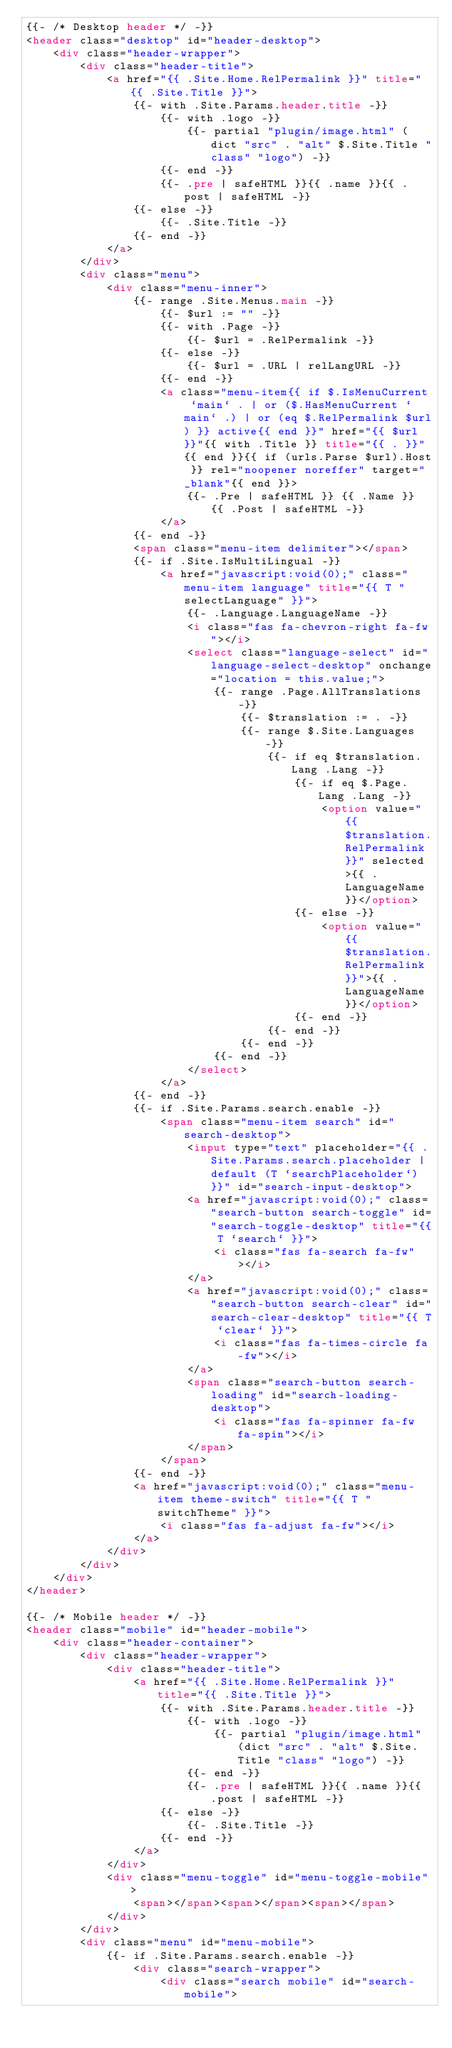<code> <loc_0><loc_0><loc_500><loc_500><_HTML_>{{- /* Desktop header */ -}}
<header class="desktop" id="header-desktop">
    <div class="header-wrapper">
        <div class="header-title">
            <a href="{{ .Site.Home.RelPermalink }}" title="{{ .Site.Title }}">
                {{- with .Site.Params.header.title -}}
                    {{- with .logo -}}
                        {{- partial "plugin/image.html" (dict "src" . "alt" $.Site.Title "class" "logo") -}}
                    {{- end -}}
                    {{- .pre | safeHTML }}{{ .name }}{{ .post | safeHTML -}}
                {{- else -}}
                    {{- .Site.Title -}}
                {{- end -}}
            </a>
        </div>
        <div class="menu">
            <div class="menu-inner">
                {{- range .Site.Menus.main -}}
                    {{- $url := "" -}}
                    {{- with .Page -}}
                        {{- $url = .RelPermalink -}}
                    {{- else -}}
                        {{- $url = .URL | relLangURL -}}
                    {{- end -}}
                    <a class="menu-item{{ if $.IsMenuCurrent `main` . | or ($.HasMenuCurrent `main` .) | or (eq $.RelPermalink $url) }} active{{ end }}" href="{{ $url }}"{{ with .Title }} title="{{ . }}"{{ end }}{{ if (urls.Parse $url).Host }} rel="noopener noreffer" target="_blank"{{ end }}>
                        {{- .Pre | safeHTML }} {{ .Name }} {{ .Post | safeHTML -}}
                    </a>
                {{- end -}}
                <span class="menu-item delimiter"></span>
                {{- if .Site.IsMultiLingual -}}
                    <a href="javascript:void(0);" class="menu-item language" title="{{ T "selectLanguage" }}">
                        {{- .Language.LanguageName -}}
                        <i class="fas fa-chevron-right fa-fw"></i>
                        <select class="language-select" id="language-select-desktop" onchange="location = this.value;">
                            {{- range .Page.AllTranslations -}}
                                {{- $translation := . -}}
                                {{- range $.Site.Languages -}}
                                    {{- if eq $translation.Lang .Lang -}}
                                        {{- if eq $.Page.Lang .Lang -}}
                                            <option value="{{ $translation.RelPermalink }}" selected>{{ .LanguageName }}</option>
                                        {{- else -}}
                                            <option value="{{ $translation.RelPermalink }}">{{ .LanguageName }}</option>
                                        {{- end -}}
                                    {{- end -}}
                                {{- end -}}
                            {{- end -}}
                        </select>
                    </a>
                {{- end -}}
                {{- if .Site.Params.search.enable -}}
                    <span class="menu-item search" id="search-desktop">
                        <input type="text" placeholder="{{ .Site.Params.search.placeholder | default (T `searchPlaceholder`) }}" id="search-input-desktop">
                        <a href="javascript:void(0);" class="search-button search-toggle" id="search-toggle-desktop" title="{{ T `search` }}">
                            <i class="fas fa-search fa-fw"></i>
                        </a>
                        <a href="javascript:void(0);" class="search-button search-clear" id="search-clear-desktop" title="{{ T `clear` }}">
                            <i class="fas fa-times-circle fa-fw"></i>
                        </a>
                        <span class="search-button search-loading" id="search-loading-desktop">
                            <i class="fas fa-spinner fa-fw fa-spin"></i>
                        </span>
                    </span>
                {{- end -}}
                <a href="javascript:void(0);" class="menu-item theme-switch" title="{{ T "switchTheme" }}">
                    <i class="fas fa-adjust fa-fw"></i>
                </a>
            </div>
        </div>
    </div>
</header>

{{- /* Mobile header */ -}}
<header class="mobile" id="header-mobile">
    <div class="header-container">
        <div class="header-wrapper">
            <div class="header-title">
                <a href="{{ .Site.Home.RelPermalink }}" title="{{ .Site.Title }}">
                    {{- with .Site.Params.header.title -}}
                        {{- with .logo -}}
                            {{- partial "plugin/image.html" (dict "src" . "alt" $.Site.Title "class" "logo") -}}
                        {{- end -}}
                        {{- .pre | safeHTML }}{{ .name }}{{ .post | safeHTML -}}
                    {{- else -}}
                        {{- .Site.Title -}}
                    {{- end -}}
                </a>
            </div>
            <div class="menu-toggle" id="menu-toggle-mobile">
                <span></span><span></span><span></span>
            </div>
        </div>
        <div class="menu" id="menu-mobile">
            {{- if .Site.Params.search.enable -}}
                <div class="search-wrapper">
                    <div class="search mobile" id="search-mobile"></code> 